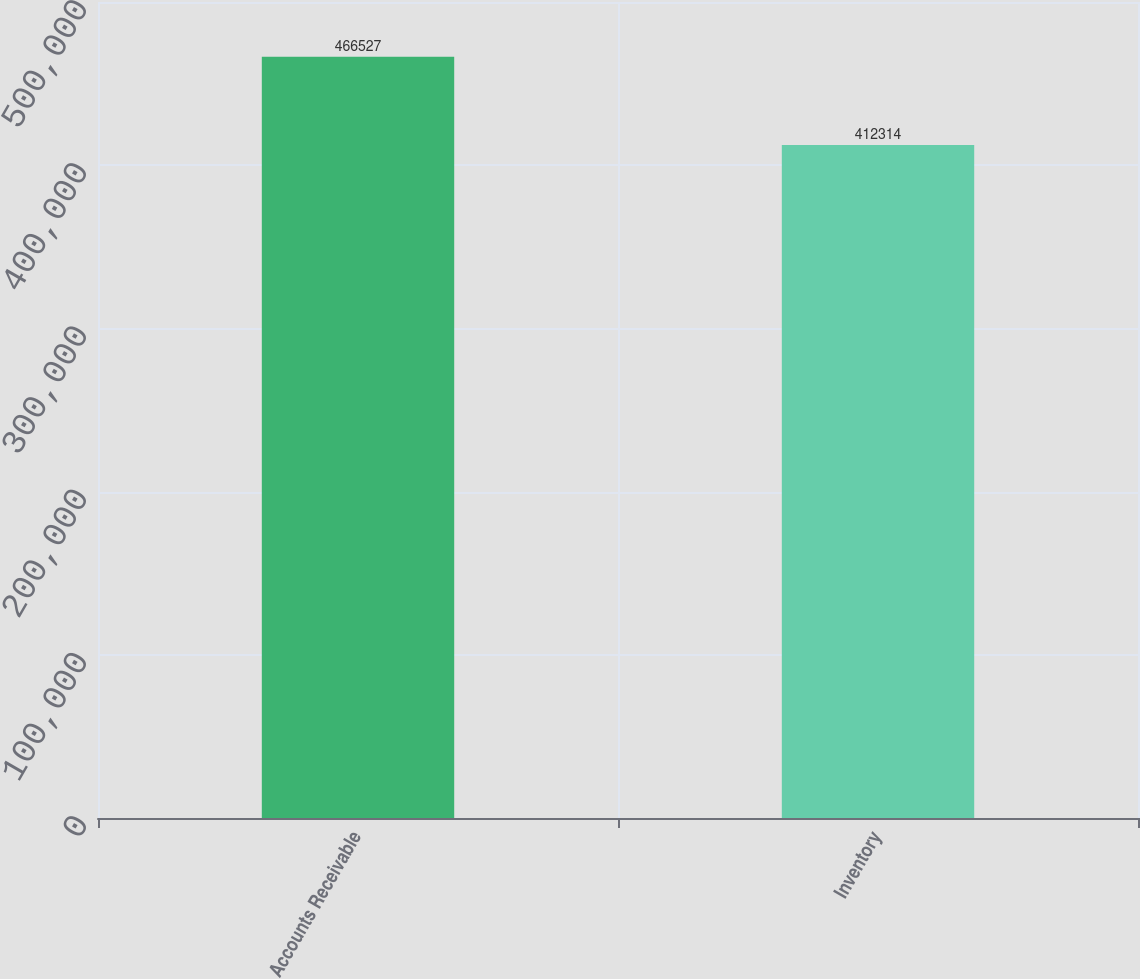<chart> <loc_0><loc_0><loc_500><loc_500><bar_chart><fcel>Accounts Receivable<fcel>Inventory<nl><fcel>466527<fcel>412314<nl></chart> 